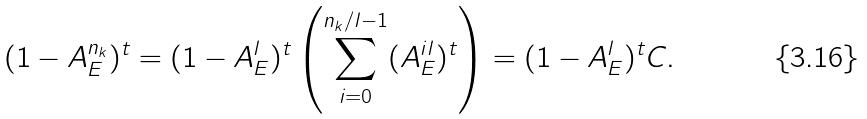<formula> <loc_0><loc_0><loc_500><loc_500>( 1 - A _ { E } ^ { n _ { k } } ) ^ { t } = ( 1 - A _ { E } ^ { l } ) ^ { t } \left ( \sum _ { i = 0 } ^ { n _ { k } / l - 1 } ( A _ { E } ^ { i l } ) ^ { t } \right ) = ( 1 - A _ { E } ^ { l } ) ^ { t } C .</formula> 